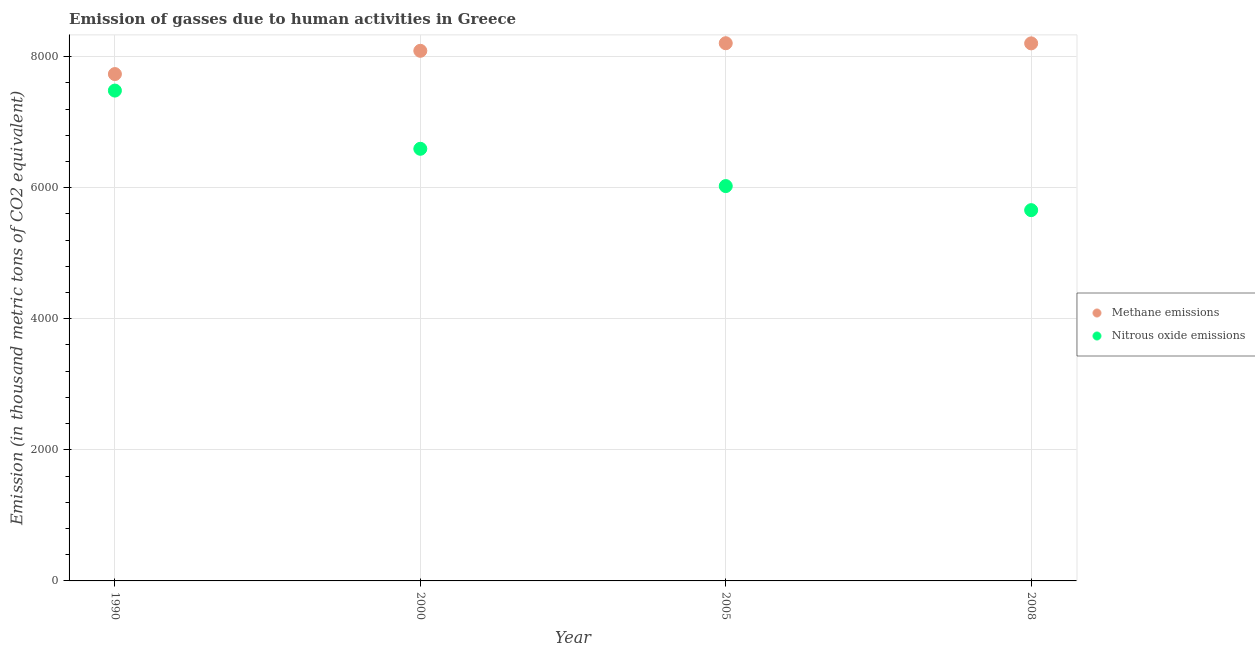How many different coloured dotlines are there?
Your answer should be very brief. 2. What is the amount of nitrous oxide emissions in 2005?
Your response must be concise. 6025. Across all years, what is the maximum amount of methane emissions?
Keep it short and to the point. 8204.9. Across all years, what is the minimum amount of methane emissions?
Your response must be concise. 7734.1. In which year was the amount of nitrous oxide emissions maximum?
Give a very brief answer. 1990. What is the total amount of nitrous oxide emissions in the graph?
Your response must be concise. 2.58e+04. What is the difference between the amount of nitrous oxide emissions in 2005 and that in 2008?
Your answer should be very brief. 367.3. What is the difference between the amount of methane emissions in 2008 and the amount of nitrous oxide emissions in 2005?
Your response must be concise. 2177.6. What is the average amount of nitrous oxide emissions per year?
Give a very brief answer. 6439.73. In the year 2000, what is the difference between the amount of methane emissions and amount of nitrous oxide emissions?
Offer a very short reply. 1495.2. In how many years, is the amount of nitrous oxide emissions greater than 5600 thousand metric tons?
Give a very brief answer. 4. What is the ratio of the amount of nitrous oxide emissions in 2000 to that in 2005?
Offer a terse response. 1.09. Is the amount of methane emissions in 1990 less than that in 2008?
Your answer should be compact. Yes. What is the difference between the highest and the second highest amount of nitrous oxide emissions?
Ensure brevity in your answer.  888.2. What is the difference between the highest and the lowest amount of methane emissions?
Your answer should be very brief. 470.8. In how many years, is the amount of methane emissions greater than the average amount of methane emissions taken over all years?
Offer a terse response. 3. Is the amount of nitrous oxide emissions strictly less than the amount of methane emissions over the years?
Ensure brevity in your answer.  Yes. What is the difference between two consecutive major ticks on the Y-axis?
Your response must be concise. 2000. Does the graph contain any zero values?
Make the answer very short. No. Does the graph contain grids?
Ensure brevity in your answer.  Yes. How many legend labels are there?
Your response must be concise. 2. How are the legend labels stacked?
Your answer should be very brief. Vertical. What is the title of the graph?
Provide a succinct answer. Emission of gasses due to human activities in Greece. Does "IMF nonconcessional" appear as one of the legend labels in the graph?
Make the answer very short. No. What is the label or title of the X-axis?
Provide a succinct answer. Year. What is the label or title of the Y-axis?
Provide a short and direct response. Emission (in thousand metric tons of CO2 equivalent). What is the Emission (in thousand metric tons of CO2 equivalent) in Methane emissions in 1990?
Your response must be concise. 7734.1. What is the Emission (in thousand metric tons of CO2 equivalent) of Nitrous oxide emissions in 1990?
Ensure brevity in your answer.  7482.2. What is the Emission (in thousand metric tons of CO2 equivalent) of Methane emissions in 2000?
Keep it short and to the point. 8089.2. What is the Emission (in thousand metric tons of CO2 equivalent) in Nitrous oxide emissions in 2000?
Offer a very short reply. 6594. What is the Emission (in thousand metric tons of CO2 equivalent) of Methane emissions in 2005?
Your response must be concise. 8204.9. What is the Emission (in thousand metric tons of CO2 equivalent) of Nitrous oxide emissions in 2005?
Offer a very short reply. 6025. What is the Emission (in thousand metric tons of CO2 equivalent) of Methane emissions in 2008?
Provide a short and direct response. 8202.6. What is the Emission (in thousand metric tons of CO2 equivalent) of Nitrous oxide emissions in 2008?
Provide a short and direct response. 5657.7. Across all years, what is the maximum Emission (in thousand metric tons of CO2 equivalent) in Methane emissions?
Offer a very short reply. 8204.9. Across all years, what is the maximum Emission (in thousand metric tons of CO2 equivalent) in Nitrous oxide emissions?
Provide a short and direct response. 7482.2. Across all years, what is the minimum Emission (in thousand metric tons of CO2 equivalent) of Methane emissions?
Give a very brief answer. 7734.1. Across all years, what is the minimum Emission (in thousand metric tons of CO2 equivalent) of Nitrous oxide emissions?
Your response must be concise. 5657.7. What is the total Emission (in thousand metric tons of CO2 equivalent) in Methane emissions in the graph?
Provide a short and direct response. 3.22e+04. What is the total Emission (in thousand metric tons of CO2 equivalent) in Nitrous oxide emissions in the graph?
Make the answer very short. 2.58e+04. What is the difference between the Emission (in thousand metric tons of CO2 equivalent) in Methane emissions in 1990 and that in 2000?
Your answer should be very brief. -355.1. What is the difference between the Emission (in thousand metric tons of CO2 equivalent) of Nitrous oxide emissions in 1990 and that in 2000?
Provide a succinct answer. 888.2. What is the difference between the Emission (in thousand metric tons of CO2 equivalent) of Methane emissions in 1990 and that in 2005?
Your response must be concise. -470.8. What is the difference between the Emission (in thousand metric tons of CO2 equivalent) in Nitrous oxide emissions in 1990 and that in 2005?
Your response must be concise. 1457.2. What is the difference between the Emission (in thousand metric tons of CO2 equivalent) of Methane emissions in 1990 and that in 2008?
Give a very brief answer. -468.5. What is the difference between the Emission (in thousand metric tons of CO2 equivalent) of Nitrous oxide emissions in 1990 and that in 2008?
Offer a very short reply. 1824.5. What is the difference between the Emission (in thousand metric tons of CO2 equivalent) of Methane emissions in 2000 and that in 2005?
Your answer should be compact. -115.7. What is the difference between the Emission (in thousand metric tons of CO2 equivalent) of Nitrous oxide emissions in 2000 and that in 2005?
Your response must be concise. 569. What is the difference between the Emission (in thousand metric tons of CO2 equivalent) of Methane emissions in 2000 and that in 2008?
Provide a short and direct response. -113.4. What is the difference between the Emission (in thousand metric tons of CO2 equivalent) of Nitrous oxide emissions in 2000 and that in 2008?
Your answer should be compact. 936.3. What is the difference between the Emission (in thousand metric tons of CO2 equivalent) in Nitrous oxide emissions in 2005 and that in 2008?
Give a very brief answer. 367.3. What is the difference between the Emission (in thousand metric tons of CO2 equivalent) in Methane emissions in 1990 and the Emission (in thousand metric tons of CO2 equivalent) in Nitrous oxide emissions in 2000?
Give a very brief answer. 1140.1. What is the difference between the Emission (in thousand metric tons of CO2 equivalent) of Methane emissions in 1990 and the Emission (in thousand metric tons of CO2 equivalent) of Nitrous oxide emissions in 2005?
Offer a terse response. 1709.1. What is the difference between the Emission (in thousand metric tons of CO2 equivalent) in Methane emissions in 1990 and the Emission (in thousand metric tons of CO2 equivalent) in Nitrous oxide emissions in 2008?
Provide a short and direct response. 2076.4. What is the difference between the Emission (in thousand metric tons of CO2 equivalent) in Methane emissions in 2000 and the Emission (in thousand metric tons of CO2 equivalent) in Nitrous oxide emissions in 2005?
Keep it short and to the point. 2064.2. What is the difference between the Emission (in thousand metric tons of CO2 equivalent) of Methane emissions in 2000 and the Emission (in thousand metric tons of CO2 equivalent) of Nitrous oxide emissions in 2008?
Offer a very short reply. 2431.5. What is the difference between the Emission (in thousand metric tons of CO2 equivalent) in Methane emissions in 2005 and the Emission (in thousand metric tons of CO2 equivalent) in Nitrous oxide emissions in 2008?
Your answer should be compact. 2547.2. What is the average Emission (in thousand metric tons of CO2 equivalent) in Methane emissions per year?
Provide a succinct answer. 8057.7. What is the average Emission (in thousand metric tons of CO2 equivalent) in Nitrous oxide emissions per year?
Make the answer very short. 6439.73. In the year 1990, what is the difference between the Emission (in thousand metric tons of CO2 equivalent) of Methane emissions and Emission (in thousand metric tons of CO2 equivalent) of Nitrous oxide emissions?
Offer a terse response. 251.9. In the year 2000, what is the difference between the Emission (in thousand metric tons of CO2 equivalent) of Methane emissions and Emission (in thousand metric tons of CO2 equivalent) of Nitrous oxide emissions?
Your answer should be very brief. 1495.2. In the year 2005, what is the difference between the Emission (in thousand metric tons of CO2 equivalent) in Methane emissions and Emission (in thousand metric tons of CO2 equivalent) in Nitrous oxide emissions?
Ensure brevity in your answer.  2179.9. In the year 2008, what is the difference between the Emission (in thousand metric tons of CO2 equivalent) of Methane emissions and Emission (in thousand metric tons of CO2 equivalent) of Nitrous oxide emissions?
Offer a terse response. 2544.9. What is the ratio of the Emission (in thousand metric tons of CO2 equivalent) of Methane emissions in 1990 to that in 2000?
Your answer should be compact. 0.96. What is the ratio of the Emission (in thousand metric tons of CO2 equivalent) of Nitrous oxide emissions in 1990 to that in 2000?
Make the answer very short. 1.13. What is the ratio of the Emission (in thousand metric tons of CO2 equivalent) of Methane emissions in 1990 to that in 2005?
Make the answer very short. 0.94. What is the ratio of the Emission (in thousand metric tons of CO2 equivalent) of Nitrous oxide emissions in 1990 to that in 2005?
Offer a very short reply. 1.24. What is the ratio of the Emission (in thousand metric tons of CO2 equivalent) in Methane emissions in 1990 to that in 2008?
Ensure brevity in your answer.  0.94. What is the ratio of the Emission (in thousand metric tons of CO2 equivalent) in Nitrous oxide emissions in 1990 to that in 2008?
Your answer should be compact. 1.32. What is the ratio of the Emission (in thousand metric tons of CO2 equivalent) in Methane emissions in 2000 to that in 2005?
Provide a succinct answer. 0.99. What is the ratio of the Emission (in thousand metric tons of CO2 equivalent) of Nitrous oxide emissions in 2000 to that in 2005?
Provide a succinct answer. 1.09. What is the ratio of the Emission (in thousand metric tons of CO2 equivalent) in Methane emissions in 2000 to that in 2008?
Your answer should be compact. 0.99. What is the ratio of the Emission (in thousand metric tons of CO2 equivalent) of Nitrous oxide emissions in 2000 to that in 2008?
Give a very brief answer. 1.17. What is the ratio of the Emission (in thousand metric tons of CO2 equivalent) of Methane emissions in 2005 to that in 2008?
Offer a very short reply. 1. What is the ratio of the Emission (in thousand metric tons of CO2 equivalent) of Nitrous oxide emissions in 2005 to that in 2008?
Your answer should be very brief. 1.06. What is the difference between the highest and the second highest Emission (in thousand metric tons of CO2 equivalent) in Methane emissions?
Keep it short and to the point. 2.3. What is the difference between the highest and the second highest Emission (in thousand metric tons of CO2 equivalent) of Nitrous oxide emissions?
Provide a short and direct response. 888.2. What is the difference between the highest and the lowest Emission (in thousand metric tons of CO2 equivalent) in Methane emissions?
Provide a short and direct response. 470.8. What is the difference between the highest and the lowest Emission (in thousand metric tons of CO2 equivalent) of Nitrous oxide emissions?
Give a very brief answer. 1824.5. 